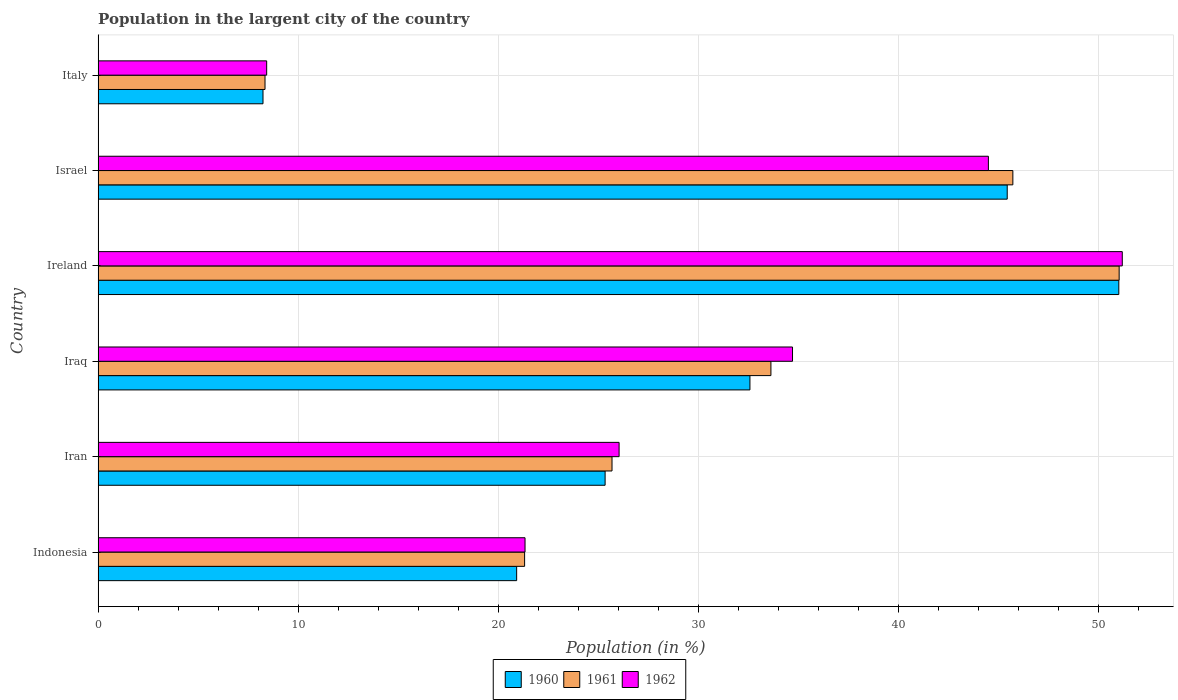How many different coloured bars are there?
Your answer should be compact. 3. How many groups of bars are there?
Give a very brief answer. 6. Are the number of bars per tick equal to the number of legend labels?
Your answer should be very brief. Yes. How many bars are there on the 1st tick from the top?
Your answer should be compact. 3. What is the label of the 3rd group of bars from the top?
Your answer should be compact. Ireland. In how many cases, is the number of bars for a given country not equal to the number of legend labels?
Make the answer very short. 0. What is the percentage of population in the largent city in 1960 in Iran?
Provide a short and direct response. 25.34. Across all countries, what is the maximum percentage of population in the largent city in 1962?
Provide a short and direct response. 51.19. Across all countries, what is the minimum percentage of population in the largent city in 1961?
Your answer should be compact. 8.34. In which country was the percentage of population in the largent city in 1960 maximum?
Offer a terse response. Ireland. In which country was the percentage of population in the largent city in 1962 minimum?
Give a very brief answer. Italy. What is the total percentage of population in the largent city in 1962 in the graph?
Provide a succinct answer. 186.19. What is the difference between the percentage of population in the largent city in 1962 in Iraq and that in Israel?
Your answer should be very brief. -9.79. What is the difference between the percentage of population in the largent city in 1962 in Iran and the percentage of population in the largent city in 1961 in Indonesia?
Your response must be concise. 4.72. What is the average percentage of population in the largent city in 1961 per country?
Offer a terse response. 30.95. What is the difference between the percentage of population in the largent city in 1960 and percentage of population in the largent city in 1962 in Iran?
Keep it short and to the point. -0.7. What is the ratio of the percentage of population in the largent city in 1962 in Iran to that in Iraq?
Ensure brevity in your answer.  0.75. What is the difference between the highest and the second highest percentage of population in the largent city in 1961?
Ensure brevity in your answer.  5.31. What is the difference between the highest and the lowest percentage of population in the largent city in 1962?
Give a very brief answer. 42.76. In how many countries, is the percentage of population in the largent city in 1962 greater than the average percentage of population in the largent city in 1962 taken over all countries?
Your answer should be very brief. 3. What does the 1st bar from the top in Italy represents?
Ensure brevity in your answer.  1962. Is it the case that in every country, the sum of the percentage of population in the largent city in 1960 and percentage of population in the largent city in 1962 is greater than the percentage of population in the largent city in 1961?
Offer a very short reply. Yes. How many bars are there?
Your answer should be very brief. 18. What is the difference between two consecutive major ticks on the X-axis?
Offer a terse response. 10. Does the graph contain grids?
Keep it short and to the point. Yes. Where does the legend appear in the graph?
Give a very brief answer. Bottom center. How many legend labels are there?
Keep it short and to the point. 3. What is the title of the graph?
Offer a very short reply. Population in the largent city of the country. Does "1993" appear as one of the legend labels in the graph?
Offer a terse response. No. What is the label or title of the X-axis?
Your response must be concise. Population (in %). What is the Population (in %) in 1960 in Indonesia?
Give a very brief answer. 20.92. What is the Population (in %) in 1961 in Indonesia?
Ensure brevity in your answer.  21.32. What is the Population (in %) in 1962 in Indonesia?
Keep it short and to the point. 21.34. What is the Population (in %) of 1960 in Iran?
Give a very brief answer. 25.34. What is the Population (in %) in 1961 in Iran?
Keep it short and to the point. 25.68. What is the Population (in %) in 1962 in Iran?
Offer a very short reply. 26.04. What is the Population (in %) in 1960 in Iraq?
Offer a terse response. 32.58. What is the Population (in %) of 1961 in Iraq?
Your answer should be compact. 33.63. What is the Population (in %) in 1962 in Iraq?
Your response must be concise. 34.71. What is the Population (in %) in 1960 in Ireland?
Offer a terse response. 51.01. What is the Population (in %) of 1961 in Ireland?
Your answer should be very brief. 51.03. What is the Population (in %) of 1962 in Ireland?
Ensure brevity in your answer.  51.19. What is the Population (in %) in 1960 in Israel?
Your answer should be compact. 45.44. What is the Population (in %) in 1961 in Israel?
Ensure brevity in your answer.  45.72. What is the Population (in %) in 1962 in Israel?
Make the answer very short. 44.5. What is the Population (in %) of 1960 in Italy?
Provide a succinct answer. 8.24. What is the Population (in %) of 1961 in Italy?
Provide a succinct answer. 8.34. What is the Population (in %) in 1962 in Italy?
Offer a very short reply. 8.42. Across all countries, what is the maximum Population (in %) of 1960?
Offer a terse response. 51.01. Across all countries, what is the maximum Population (in %) in 1961?
Your answer should be compact. 51.03. Across all countries, what is the maximum Population (in %) in 1962?
Your answer should be compact. 51.19. Across all countries, what is the minimum Population (in %) of 1960?
Provide a succinct answer. 8.24. Across all countries, what is the minimum Population (in %) of 1961?
Your answer should be compact. 8.34. Across all countries, what is the minimum Population (in %) of 1962?
Make the answer very short. 8.42. What is the total Population (in %) in 1960 in the graph?
Provide a short and direct response. 183.53. What is the total Population (in %) of 1961 in the graph?
Your response must be concise. 185.72. What is the total Population (in %) in 1962 in the graph?
Your answer should be very brief. 186.19. What is the difference between the Population (in %) of 1960 in Indonesia and that in Iran?
Ensure brevity in your answer.  -4.42. What is the difference between the Population (in %) in 1961 in Indonesia and that in Iran?
Keep it short and to the point. -4.37. What is the difference between the Population (in %) of 1962 in Indonesia and that in Iran?
Your answer should be compact. -4.7. What is the difference between the Population (in %) of 1960 in Indonesia and that in Iraq?
Provide a succinct answer. -11.66. What is the difference between the Population (in %) in 1961 in Indonesia and that in Iraq?
Keep it short and to the point. -12.31. What is the difference between the Population (in %) of 1962 in Indonesia and that in Iraq?
Give a very brief answer. -13.37. What is the difference between the Population (in %) of 1960 in Indonesia and that in Ireland?
Your answer should be compact. -30.1. What is the difference between the Population (in %) in 1961 in Indonesia and that in Ireland?
Make the answer very short. -29.72. What is the difference between the Population (in %) in 1962 in Indonesia and that in Ireland?
Offer a terse response. -29.85. What is the difference between the Population (in %) of 1960 in Indonesia and that in Israel?
Make the answer very short. -24.52. What is the difference between the Population (in %) in 1961 in Indonesia and that in Israel?
Ensure brevity in your answer.  -24.4. What is the difference between the Population (in %) of 1962 in Indonesia and that in Israel?
Your answer should be very brief. -23.16. What is the difference between the Population (in %) of 1960 in Indonesia and that in Italy?
Offer a terse response. 12.68. What is the difference between the Population (in %) in 1961 in Indonesia and that in Italy?
Provide a succinct answer. 12.97. What is the difference between the Population (in %) of 1962 in Indonesia and that in Italy?
Give a very brief answer. 12.91. What is the difference between the Population (in %) of 1960 in Iran and that in Iraq?
Keep it short and to the point. -7.24. What is the difference between the Population (in %) in 1961 in Iran and that in Iraq?
Ensure brevity in your answer.  -7.94. What is the difference between the Population (in %) of 1962 in Iran and that in Iraq?
Your answer should be very brief. -8.67. What is the difference between the Population (in %) of 1960 in Iran and that in Ireland?
Offer a terse response. -25.67. What is the difference between the Population (in %) in 1961 in Iran and that in Ireland?
Provide a succinct answer. -25.35. What is the difference between the Population (in %) in 1962 in Iran and that in Ireland?
Ensure brevity in your answer.  -25.15. What is the difference between the Population (in %) of 1960 in Iran and that in Israel?
Ensure brevity in your answer.  -20.1. What is the difference between the Population (in %) in 1961 in Iran and that in Israel?
Provide a short and direct response. -20.03. What is the difference between the Population (in %) in 1962 in Iran and that in Israel?
Offer a very short reply. -18.46. What is the difference between the Population (in %) of 1960 in Iran and that in Italy?
Provide a short and direct response. 17.1. What is the difference between the Population (in %) of 1961 in Iran and that in Italy?
Keep it short and to the point. 17.34. What is the difference between the Population (in %) in 1962 in Iran and that in Italy?
Your response must be concise. 17.61. What is the difference between the Population (in %) in 1960 in Iraq and that in Ireland?
Your response must be concise. -18.44. What is the difference between the Population (in %) of 1961 in Iraq and that in Ireland?
Ensure brevity in your answer.  -17.4. What is the difference between the Population (in %) in 1962 in Iraq and that in Ireland?
Keep it short and to the point. -16.48. What is the difference between the Population (in %) in 1960 in Iraq and that in Israel?
Offer a terse response. -12.86. What is the difference between the Population (in %) of 1961 in Iraq and that in Israel?
Provide a succinct answer. -12.09. What is the difference between the Population (in %) in 1962 in Iraq and that in Israel?
Provide a short and direct response. -9.79. What is the difference between the Population (in %) of 1960 in Iraq and that in Italy?
Provide a short and direct response. 24.34. What is the difference between the Population (in %) of 1961 in Iraq and that in Italy?
Keep it short and to the point. 25.29. What is the difference between the Population (in %) in 1962 in Iraq and that in Italy?
Make the answer very short. 26.28. What is the difference between the Population (in %) in 1960 in Ireland and that in Israel?
Keep it short and to the point. 5.58. What is the difference between the Population (in %) in 1961 in Ireland and that in Israel?
Keep it short and to the point. 5.31. What is the difference between the Population (in %) in 1962 in Ireland and that in Israel?
Offer a terse response. 6.69. What is the difference between the Population (in %) in 1960 in Ireland and that in Italy?
Make the answer very short. 42.77. What is the difference between the Population (in %) in 1961 in Ireland and that in Italy?
Keep it short and to the point. 42.69. What is the difference between the Population (in %) of 1962 in Ireland and that in Italy?
Your response must be concise. 42.76. What is the difference between the Population (in %) in 1960 in Israel and that in Italy?
Make the answer very short. 37.2. What is the difference between the Population (in %) in 1961 in Israel and that in Italy?
Make the answer very short. 37.38. What is the difference between the Population (in %) of 1962 in Israel and that in Italy?
Your answer should be compact. 36.07. What is the difference between the Population (in %) of 1960 in Indonesia and the Population (in %) of 1961 in Iran?
Offer a terse response. -4.77. What is the difference between the Population (in %) in 1960 in Indonesia and the Population (in %) in 1962 in Iran?
Keep it short and to the point. -5.12. What is the difference between the Population (in %) of 1961 in Indonesia and the Population (in %) of 1962 in Iran?
Ensure brevity in your answer.  -4.72. What is the difference between the Population (in %) of 1960 in Indonesia and the Population (in %) of 1961 in Iraq?
Keep it short and to the point. -12.71. What is the difference between the Population (in %) of 1960 in Indonesia and the Population (in %) of 1962 in Iraq?
Your answer should be very brief. -13.79. What is the difference between the Population (in %) in 1961 in Indonesia and the Population (in %) in 1962 in Iraq?
Ensure brevity in your answer.  -13.39. What is the difference between the Population (in %) of 1960 in Indonesia and the Population (in %) of 1961 in Ireland?
Provide a short and direct response. -30.11. What is the difference between the Population (in %) of 1960 in Indonesia and the Population (in %) of 1962 in Ireland?
Give a very brief answer. -30.27. What is the difference between the Population (in %) in 1961 in Indonesia and the Population (in %) in 1962 in Ireland?
Give a very brief answer. -29.87. What is the difference between the Population (in %) in 1960 in Indonesia and the Population (in %) in 1961 in Israel?
Offer a terse response. -24.8. What is the difference between the Population (in %) in 1960 in Indonesia and the Population (in %) in 1962 in Israel?
Your answer should be compact. -23.58. What is the difference between the Population (in %) of 1961 in Indonesia and the Population (in %) of 1962 in Israel?
Ensure brevity in your answer.  -23.18. What is the difference between the Population (in %) of 1960 in Indonesia and the Population (in %) of 1961 in Italy?
Ensure brevity in your answer.  12.58. What is the difference between the Population (in %) in 1960 in Indonesia and the Population (in %) in 1962 in Italy?
Ensure brevity in your answer.  12.49. What is the difference between the Population (in %) in 1961 in Indonesia and the Population (in %) in 1962 in Italy?
Ensure brevity in your answer.  12.89. What is the difference between the Population (in %) in 1960 in Iran and the Population (in %) in 1961 in Iraq?
Give a very brief answer. -8.29. What is the difference between the Population (in %) in 1960 in Iran and the Population (in %) in 1962 in Iraq?
Your answer should be compact. -9.37. What is the difference between the Population (in %) of 1961 in Iran and the Population (in %) of 1962 in Iraq?
Ensure brevity in your answer.  -9.02. What is the difference between the Population (in %) in 1960 in Iran and the Population (in %) in 1961 in Ireland?
Give a very brief answer. -25.69. What is the difference between the Population (in %) in 1960 in Iran and the Population (in %) in 1962 in Ireland?
Provide a succinct answer. -25.85. What is the difference between the Population (in %) in 1961 in Iran and the Population (in %) in 1962 in Ireland?
Your response must be concise. -25.5. What is the difference between the Population (in %) in 1960 in Iran and the Population (in %) in 1961 in Israel?
Your answer should be very brief. -20.38. What is the difference between the Population (in %) in 1960 in Iran and the Population (in %) in 1962 in Israel?
Offer a very short reply. -19.16. What is the difference between the Population (in %) of 1961 in Iran and the Population (in %) of 1962 in Israel?
Ensure brevity in your answer.  -18.81. What is the difference between the Population (in %) of 1960 in Iran and the Population (in %) of 1961 in Italy?
Your answer should be very brief. 17. What is the difference between the Population (in %) of 1960 in Iran and the Population (in %) of 1962 in Italy?
Offer a terse response. 16.91. What is the difference between the Population (in %) in 1961 in Iran and the Population (in %) in 1962 in Italy?
Provide a short and direct response. 17.26. What is the difference between the Population (in %) of 1960 in Iraq and the Population (in %) of 1961 in Ireland?
Ensure brevity in your answer.  -18.45. What is the difference between the Population (in %) of 1960 in Iraq and the Population (in %) of 1962 in Ireland?
Give a very brief answer. -18.61. What is the difference between the Population (in %) of 1961 in Iraq and the Population (in %) of 1962 in Ireland?
Your answer should be compact. -17.56. What is the difference between the Population (in %) of 1960 in Iraq and the Population (in %) of 1961 in Israel?
Offer a terse response. -13.14. What is the difference between the Population (in %) of 1960 in Iraq and the Population (in %) of 1962 in Israel?
Give a very brief answer. -11.92. What is the difference between the Population (in %) in 1961 in Iraq and the Population (in %) in 1962 in Israel?
Make the answer very short. -10.87. What is the difference between the Population (in %) in 1960 in Iraq and the Population (in %) in 1961 in Italy?
Give a very brief answer. 24.24. What is the difference between the Population (in %) of 1960 in Iraq and the Population (in %) of 1962 in Italy?
Your answer should be compact. 24.15. What is the difference between the Population (in %) in 1961 in Iraq and the Population (in %) in 1962 in Italy?
Keep it short and to the point. 25.2. What is the difference between the Population (in %) in 1960 in Ireland and the Population (in %) in 1961 in Israel?
Make the answer very short. 5.29. What is the difference between the Population (in %) of 1960 in Ireland and the Population (in %) of 1962 in Israel?
Give a very brief answer. 6.52. What is the difference between the Population (in %) of 1961 in Ireland and the Population (in %) of 1962 in Israel?
Make the answer very short. 6.54. What is the difference between the Population (in %) in 1960 in Ireland and the Population (in %) in 1961 in Italy?
Keep it short and to the point. 42.67. What is the difference between the Population (in %) of 1960 in Ireland and the Population (in %) of 1962 in Italy?
Your answer should be compact. 42.59. What is the difference between the Population (in %) of 1961 in Ireland and the Population (in %) of 1962 in Italy?
Provide a succinct answer. 42.61. What is the difference between the Population (in %) in 1960 in Israel and the Population (in %) in 1961 in Italy?
Provide a short and direct response. 37.1. What is the difference between the Population (in %) in 1960 in Israel and the Population (in %) in 1962 in Italy?
Offer a terse response. 37.01. What is the difference between the Population (in %) in 1961 in Israel and the Population (in %) in 1962 in Italy?
Provide a succinct answer. 37.29. What is the average Population (in %) in 1960 per country?
Offer a terse response. 30.59. What is the average Population (in %) in 1961 per country?
Provide a succinct answer. 30.95. What is the average Population (in %) of 1962 per country?
Give a very brief answer. 31.03. What is the difference between the Population (in %) of 1960 and Population (in %) of 1961 in Indonesia?
Keep it short and to the point. -0.4. What is the difference between the Population (in %) of 1960 and Population (in %) of 1962 in Indonesia?
Provide a succinct answer. -0.42. What is the difference between the Population (in %) in 1961 and Population (in %) in 1962 in Indonesia?
Ensure brevity in your answer.  -0.02. What is the difference between the Population (in %) of 1960 and Population (in %) of 1961 in Iran?
Your answer should be very brief. -0.35. What is the difference between the Population (in %) of 1960 and Population (in %) of 1962 in Iran?
Your response must be concise. -0.7. What is the difference between the Population (in %) in 1961 and Population (in %) in 1962 in Iran?
Provide a short and direct response. -0.35. What is the difference between the Population (in %) of 1960 and Population (in %) of 1961 in Iraq?
Offer a very short reply. -1.05. What is the difference between the Population (in %) of 1960 and Population (in %) of 1962 in Iraq?
Make the answer very short. -2.13. What is the difference between the Population (in %) of 1961 and Population (in %) of 1962 in Iraq?
Your answer should be compact. -1.08. What is the difference between the Population (in %) in 1960 and Population (in %) in 1961 in Ireland?
Keep it short and to the point. -0.02. What is the difference between the Population (in %) in 1960 and Population (in %) in 1962 in Ireland?
Offer a very short reply. -0.17. What is the difference between the Population (in %) of 1961 and Population (in %) of 1962 in Ireland?
Keep it short and to the point. -0.16. What is the difference between the Population (in %) of 1960 and Population (in %) of 1961 in Israel?
Provide a short and direct response. -0.28. What is the difference between the Population (in %) of 1960 and Population (in %) of 1962 in Israel?
Offer a very short reply. 0.94. What is the difference between the Population (in %) in 1961 and Population (in %) in 1962 in Israel?
Ensure brevity in your answer.  1.22. What is the difference between the Population (in %) in 1960 and Population (in %) in 1961 in Italy?
Your response must be concise. -0.1. What is the difference between the Population (in %) of 1960 and Population (in %) of 1962 in Italy?
Offer a very short reply. -0.18. What is the difference between the Population (in %) of 1961 and Population (in %) of 1962 in Italy?
Keep it short and to the point. -0.08. What is the ratio of the Population (in %) in 1960 in Indonesia to that in Iran?
Make the answer very short. 0.83. What is the ratio of the Population (in %) in 1961 in Indonesia to that in Iran?
Keep it short and to the point. 0.83. What is the ratio of the Population (in %) in 1962 in Indonesia to that in Iran?
Make the answer very short. 0.82. What is the ratio of the Population (in %) of 1960 in Indonesia to that in Iraq?
Offer a terse response. 0.64. What is the ratio of the Population (in %) of 1961 in Indonesia to that in Iraq?
Offer a very short reply. 0.63. What is the ratio of the Population (in %) in 1962 in Indonesia to that in Iraq?
Give a very brief answer. 0.61. What is the ratio of the Population (in %) in 1960 in Indonesia to that in Ireland?
Offer a terse response. 0.41. What is the ratio of the Population (in %) in 1961 in Indonesia to that in Ireland?
Offer a terse response. 0.42. What is the ratio of the Population (in %) of 1962 in Indonesia to that in Ireland?
Your answer should be compact. 0.42. What is the ratio of the Population (in %) of 1960 in Indonesia to that in Israel?
Your answer should be compact. 0.46. What is the ratio of the Population (in %) of 1961 in Indonesia to that in Israel?
Keep it short and to the point. 0.47. What is the ratio of the Population (in %) of 1962 in Indonesia to that in Israel?
Offer a very short reply. 0.48. What is the ratio of the Population (in %) of 1960 in Indonesia to that in Italy?
Keep it short and to the point. 2.54. What is the ratio of the Population (in %) in 1961 in Indonesia to that in Italy?
Keep it short and to the point. 2.56. What is the ratio of the Population (in %) of 1962 in Indonesia to that in Italy?
Ensure brevity in your answer.  2.53. What is the ratio of the Population (in %) of 1961 in Iran to that in Iraq?
Your answer should be very brief. 0.76. What is the ratio of the Population (in %) in 1962 in Iran to that in Iraq?
Make the answer very short. 0.75. What is the ratio of the Population (in %) in 1960 in Iran to that in Ireland?
Your answer should be very brief. 0.5. What is the ratio of the Population (in %) in 1961 in Iran to that in Ireland?
Offer a very short reply. 0.5. What is the ratio of the Population (in %) of 1962 in Iran to that in Ireland?
Your answer should be very brief. 0.51. What is the ratio of the Population (in %) of 1960 in Iran to that in Israel?
Your response must be concise. 0.56. What is the ratio of the Population (in %) of 1961 in Iran to that in Israel?
Your answer should be very brief. 0.56. What is the ratio of the Population (in %) in 1962 in Iran to that in Israel?
Make the answer very short. 0.59. What is the ratio of the Population (in %) of 1960 in Iran to that in Italy?
Ensure brevity in your answer.  3.08. What is the ratio of the Population (in %) of 1961 in Iran to that in Italy?
Offer a terse response. 3.08. What is the ratio of the Population (in %) in 1962 in Iran to that in Italy?
Your response must be concise. 3.09. What is the ratio of the Population (in %) in 1960 in Iraq to that in Ireland?
Your answer should be compact. 0.64. What is the ratio of the Population (in %) in 1961 in Iraq to that in Ireland?
Make the answer very short. 0.66. What is the ratio of the Population (in %) of 1962 in Iraq to that in Ireland?
Make the answer very short. 0.68. What is the ratio of the Population (in %) in 1960 in Iraq to that in Israel?
Offer a very short reply. 0.72. What is the ratio of the Population (in %) of 1961 in Iraq to that in Israel?
Offer a very short reply. 0.74. What is the ratio of the Population (in %) of 1962 in Iraq to that in Israel?
Ensure brevity in your answer.  0.78. What is the ratio of the Population (in %) in 1960 in Iraq to that in Italy?
Make the answer very short. 3.95. What is the ratio of the Population (in %) of 1961 in Iraq to that in Italy?
Your answer should be compact. 4.03. What is the ratio of the Population (in %) in 1962 in Iraq to that in Italy?
Provide a succinct answer. 4.12. What is the ratio of the Population (in %) in 1960 in Ireland to that in Israel?
Your answer should be compact. 1.12. What is the ratio of the Population (in %) of 1961 in Ireland to that in Israel?
Your answer should be compact. 1.12. What is the ratio of the Population (in %) in 1962 in Ireland to that in Israel?
Make the answer very short. 1.15. What is the ratio of the Population (in %) in 1960 in Ireland to that in Italy?
Your response must be concise. 6.19. What is the ratio of the Population (in %) in 1961 in Ireland to that in Italy?
Ensure brevity in your answer.  6.12. What is the ratio of the Population (in %) in 1962 in Ireland to that in Italy?
Offer a terse response. 6.08. What is the ratio of the Population (in %) in 1960 in Israel to that in Italy?
Provide a short and direct response. 5.51. What is the ratio of the Population (in %) of 1961 in Israel to that in Italy?
Make the answer very short. 5.48. What is the ratio of the Population (in %) in 1962 in Israel to that in Italy?
Give a very brief answer. 5.28. What is the difference between the highest and the second highest Population (in %) of 1960?
Make the answer very short. 5.58. What is the difference between the highest and the second highest Population (in %) of 1961?
Offer a very short reply. 5.31. What is the difference between the highest and the second highest Population (in %) in 1962?
Your response must be concise. 6.69. What is the difference between the highest and the lowest Population (in %) of 1960?
Provide a succinct answer. 42.77. What is the difference between the highest and the lowest Population (in %) in 1961?
Make the answer very short. 42.69. What is the difference between the highest and the lowest Population (in %) of 1962?
Give a very brief answer. 42.76. 